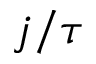Convert formula to latex. <formula><loc_0><loc_0><loc_500><loc_500>j / \tau</formula> 